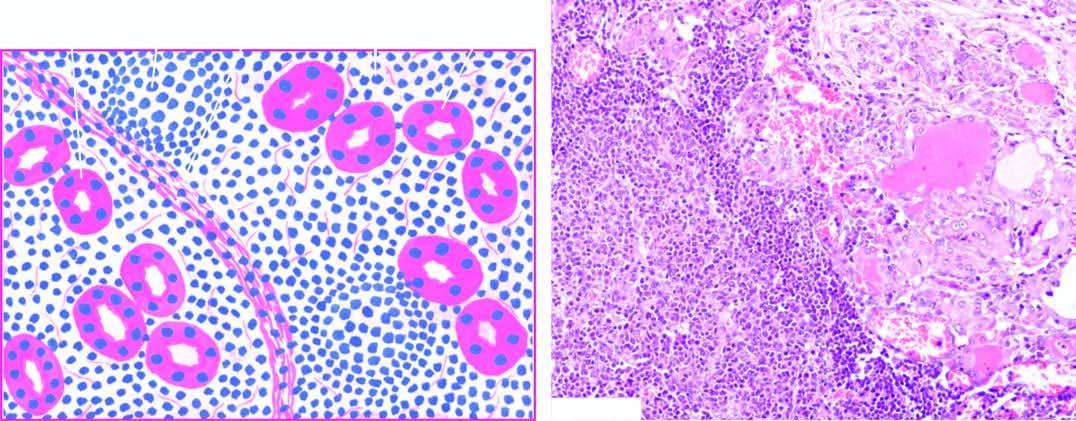do histologic features include: lymphoid cell infiltration with formation of lymphoid follicles having germinal centres ; small, atrophic and colloid-deficient follicles ; presence of hurthle cells which have granular oxyphil cytoplasm and large irregular
Answer the question using a single word or phrase. Yes 